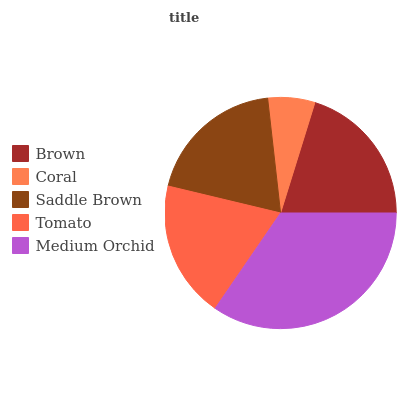Is Coral the minimum?
Answer yes or no. Yes. Is Medium Orchid the maximum?
Answer yes or no. Yes. Is Saddle Brown the minimum?
Answer yes or no. No. Is Saddle Brown the maximum?
Answer yes or no. No. Is Saddle Brown greater than Coral?
Answer yes or no. Yes. Is Coral less than Saddle Brown?
Answer yes or no. Yes. Is Coral greater than Saddle Brown?
Answer yes or no. No. Is Saddle Brown less than Coral?
Answer yes or no. No. Is Saddle Brown the high median?
Answer yes or no. Yes. Is Saddle Brown the low median?
Answer yes or no. Yes. Is Tomato the high median?
Answer yes or no. No. Is Coral the low median?
Answer yes or no. No. 